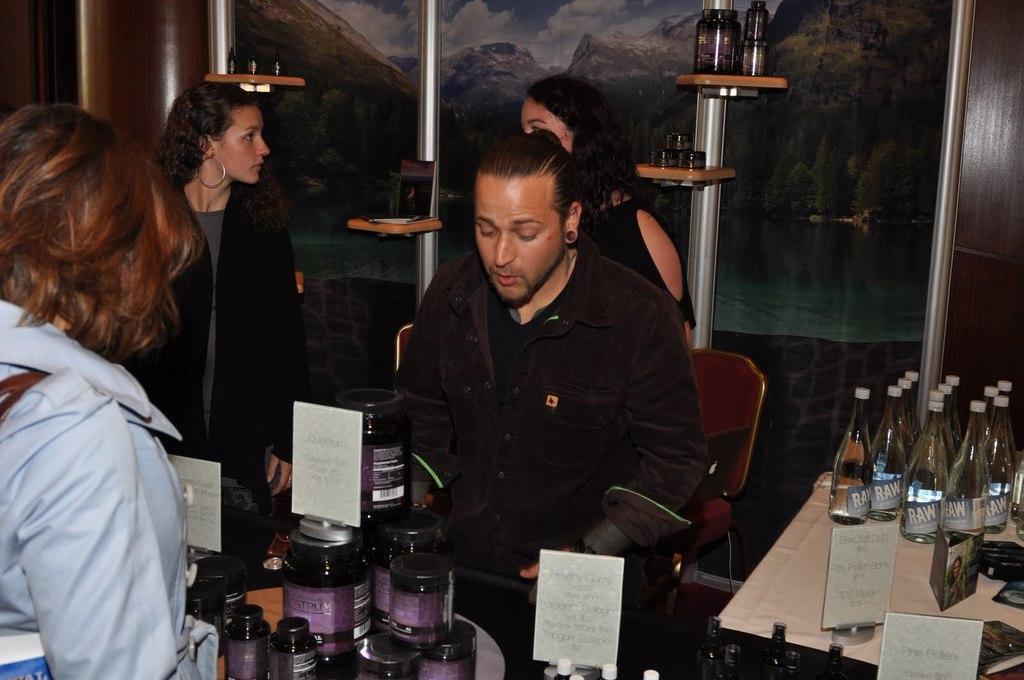Please provide a concise description of this image. In this picture we can see some people are standing, three are women and one is man near the desk, on the desk we can see some bottles of drinks, in the background we can see a poles and a wooden stand on it and also we can see some bottles, in the behind it we can see a poster. 